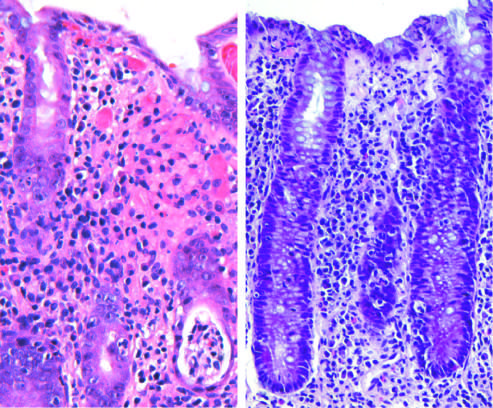how is enteroinvasive escherichia coli infection?
Answer the question using a single word or phrase. Similar to other acute 